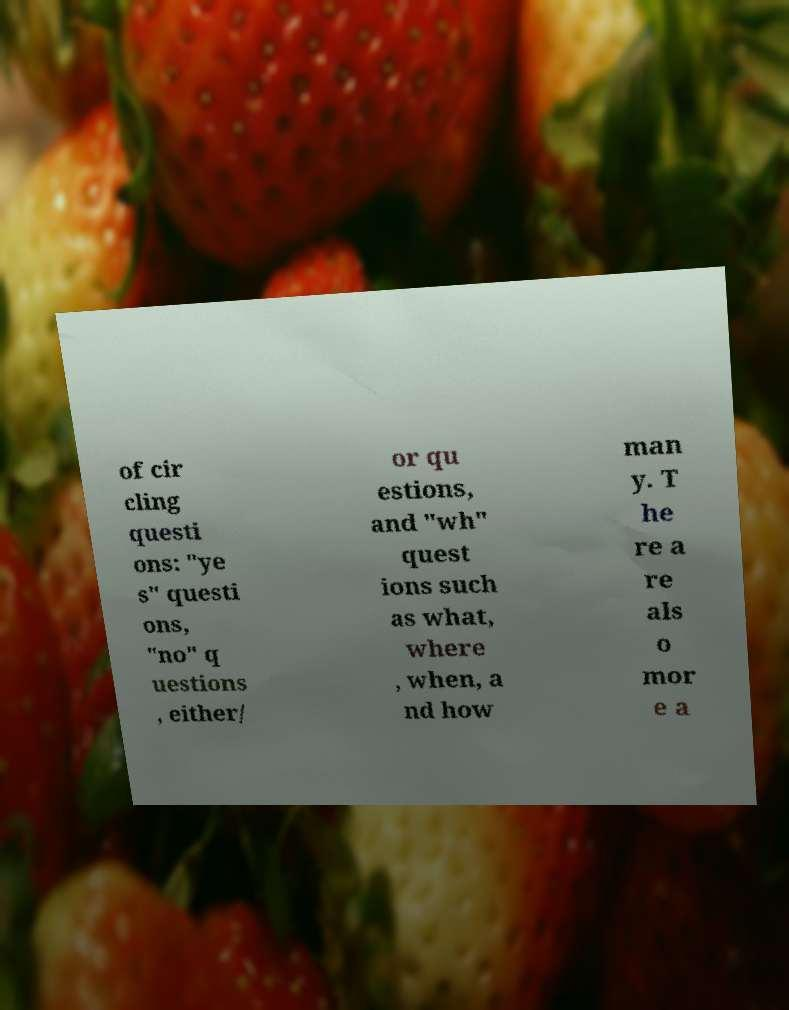What messages or text are displayed in this image? I need them in a readable, typed format. of cir cling questi ons: "ye s" questi ons, "no" q uestions , either/ or qu estions, and "wh" quest ions such as what, where , when, a nd how man y. T he re a re als o mor e a 